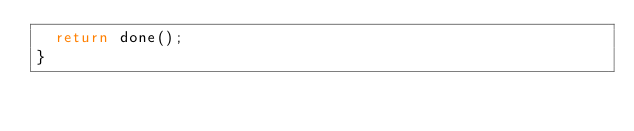<code> <loc_0><loc_0><loc_500><loc_500><_JavaScript_>  return done();
}
</code> 